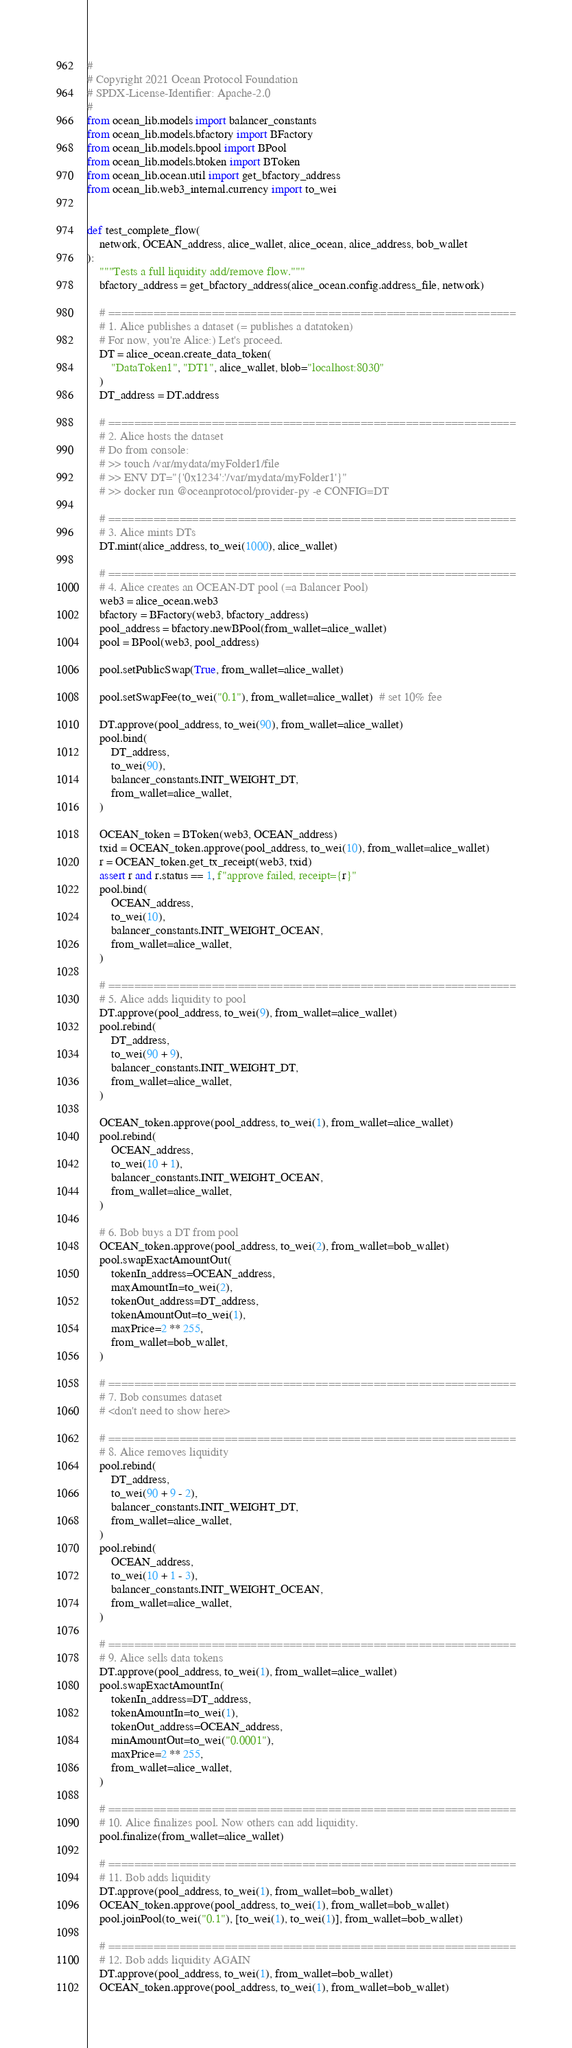<code> <loc_0><loc_0><loc_500><loc_500><_Python_>#
# Copyright 2021 Ocean Protocol Foundation
# SPDX-License-Identifier: Apache-2.0
#
from ocean_lib.models import balancer_constants
from ocean_lib.models.bfactory import BFactory
from ocean_lib.models.bpool import BPool
from ocean_lib.models.btoken import BToken
from ocean_lib.ocean.util import get_bfactory_address
from ocean_lib.web3_internal.currency import to_wei


def test_complete_flow(
    network, OCEAN_address, alice_wallet, alice_ocean, alice_address, bob_wallet
):
    """Tests a full liquidity add/remove flow."""
    bfactory_address = get_bfactory_address(alice_ocean.config.address_file, network)

    # ===============================================================
    # 1. Alice publishes a dataset (= publishes a datatoken)
    # For now, you're Alice:) Let's proceed.
    DT = alice_ocean.create_data_token(
        "DataToken1", "DT1", alice_wallet, blob="localhost:8030"
    )
    DT_address = DT.address

    # ===============================================================
    # 2. Alice hosts the dataset
    # Do from console:
    # >> touch /var/mydata/myFolder1/file
    # >> ENV DT="{'0x1234':'/var/mydata/myFolder1'}"
    # >> docker run @oceanprotocol/provider-py -e CONFIG=DT

    # ===============================================================
    # 3. Alice mints DTs
    DT.mint(alice_address, to_wei(1000), alice_wallet)

    # ===============================================================
    # 4. Alice creates an OCEAN-DT pool (=a Balancer Pool)
    web3 = alice_ocean.web3
    bfactory = BFactory(web3, bfactory_address)
    pool_address = bfactory.newBPool(from_wallet=alice_wallet)
    pool = BPool(web3, pool_address)

    pool.setPublicSwap(True, from_wallet=alice_wallet)

    pool.setSwapFee(to_wei("0.1"), from_wallet=alice_wallet)  # set 10% fee

    DT.approve(pool_address, to_wei(90), from_wallet=alice_wallet)
    pool.bind(
        DT_address,
        to_wei(90),
        balancer_constants.INIT_WEIGHT_DT,
        from_wallet=alice_wallet,
    )

    OCEAN_token = BToken(web3, OCEAN_address)
    txid = OCEAN_token.approve(pool_address, to_wei(10), from_wallet=alice_wallet)
    r = OCEAN_token.get_tx_receipt(web3, txid)
    assert r and r.status == 1, f"approve failed, receipt={r}"
    pool.bind(
        OCEAN_address,
        to_wei(10),
        balancer_constants.INIT_WEIGHT_OCEAN,
        from_wallet=alice_wallet,
    )

    # ===============================================================
    # 5. Alice adds liquidity to pool
    DT.approve(pool_address, to_wei(9), from_wallet=alice_wallet)
    pool.rebind(
        DT_address,
        to_wei(90 + 9),
        balancer_constants.INIT_WEIGHT_DT,
        from_wallet=alice_wallet,
    )

    OCEAN_token.approve(pool_address, to_wei(1), from_wallet=alice_wallet)
    pool.rebind(
        OCEAN_address,
        to_wei(10 + 1),
        balancer_constants.INIT_WEIGHT_OCEAN,
        from_wallet=alice_wallet,
    )

    # 6. Bob buys a DT from pool
    OCEAN_token.approve(pool_address, to_wei(2), from_wallet=bob_wallet)
    pool.swapExactAmountOut(
        tokenIn_address=OCEAN_address,
        maxAmountIn=to_wei(2),
        tokenOut_address=DT_address,
        tokenAmountOut=to_wei(1),
        maxPrice=2 ** 255,
        from_wallet=bob_wallet,
    )

    # ===============================================================
    # 7. Bob consumes dataset
    # <don't need to show here>

    # ===============================================================
    # 8. Alice removes liquidity
    pool.rebind(
        DT_address,
        to_wei(90 + 9 - 2),
        balancer_constants.INIT_WEIGHT_DT,
        from_wallet=alice_wallet,
    )
    pool.rebind(
        OCEAN_address,
        to_wei(10 + 1 - 3),
        balancer_constants.INIT_WEIGHT_OCEAN,
        from_wallet=alice_wallet,
    )

    # ===============================================================
    # 9. Alice sells data tokens
    DT.approve(pool_address, to_wei(1), from_wallet=alice_wallet)
    pool.swapExactAmountIn(
        tokenIn_address=DT_address,
        tokenAmountIn=to_wei(1),
        tokenOut_address=OCEAN_address,
        minAmountOut=to_wei("0.0001"),
        maxPrice=2 ** 255,
        from_wallet=alice_wallet,
    )

    # ===============================================================
    # 10. Alice finalizes pool. Now others can add liquidity.
    pool.finalize(from_wallet=alice_wallet)

    # ===============================================================
    # 11. Bob adds liquidity
    DT.approve(pool_address, to_wei(1), from_wallet=bob_wallet)
    OCEAN_token.approve(pool_address, to_wei(1), from_wallet=bob_wallet)
    pool.joinPool(to_wei("0.1"), [to_wei(1), to_wei(1)], from_wallet=bob_wallet)

    # ===============================================================
    # 12. Bob adds liquidity AGAIN
    DT.approve(pool_address, to_wei(1), from_wallet=bob_wallet)
    OCEAN_token.approve(pool_address, to_wei(1), from_wallet=bob_wallet)</code> 